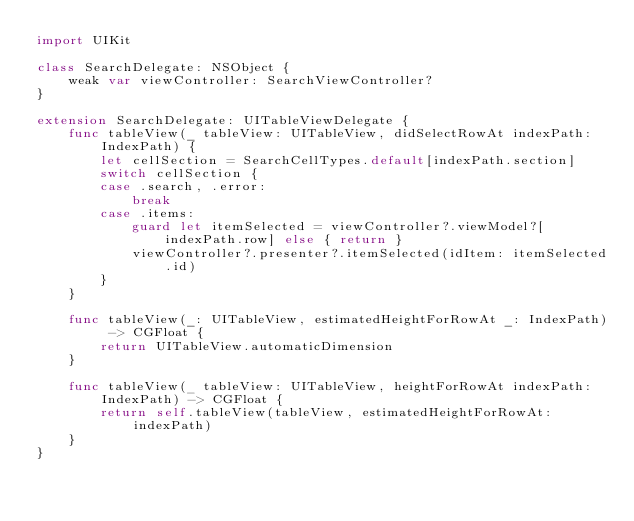Convert code to text. <code><loc_0><loc_0><loc_500><loc_500><_Swift_>import UIKit

class SearchDelegate: NSObject {
    weak var viewController: SearchViewController?
}

extension SearchDelegate: UITableViewDelegate {
    func tableView(_ tableView: UITableView, didSelectRowAt indexPath: IndexPath) {
        let cellSection = SearchCellTypes.default[indexPath.section]
        switch cellSection {
        case .search, .error:
            break
        case .items:
            guard let itemSelected = viewController?.viewModel?[indexPath.row] else { return }
            viewController?.presenter?.itemSelected(idItem: itemSelected.id)
        }
    }

    func tableView(_: UITableView, estimatedHeightForRowAt _: IndexPath) -> CGFloat {
        return UITableView.automaticDimension
    }

    func tableView(_ tableView: UITableView, heightForRowAt indexPath: IndexPath) -> CGFloat {
        return self.tableView(tableView, estimatedHeightForRowAt: indexPath)
    }
}
</code> 